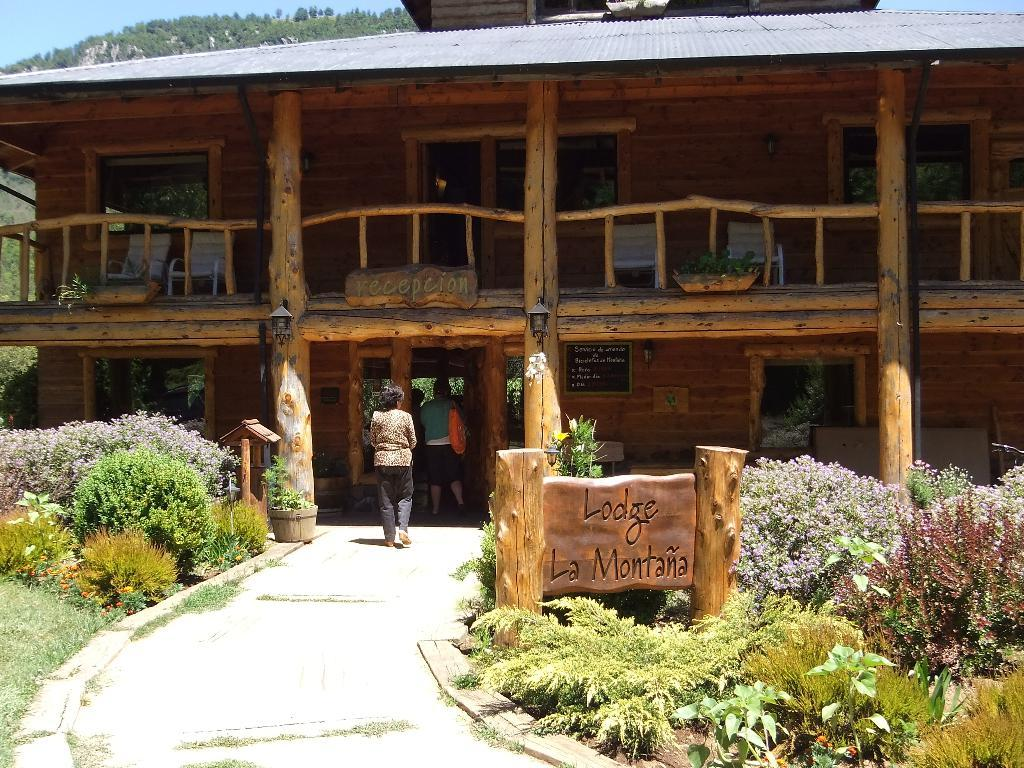Provide a one-sentence caption for the provided image. A wood two story building with a sign out front that says Lodge La Montana. 